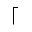Convert formula to latex. <formula><loc_0><loc_0><loc_500><loc_500>\lceil</formula> 